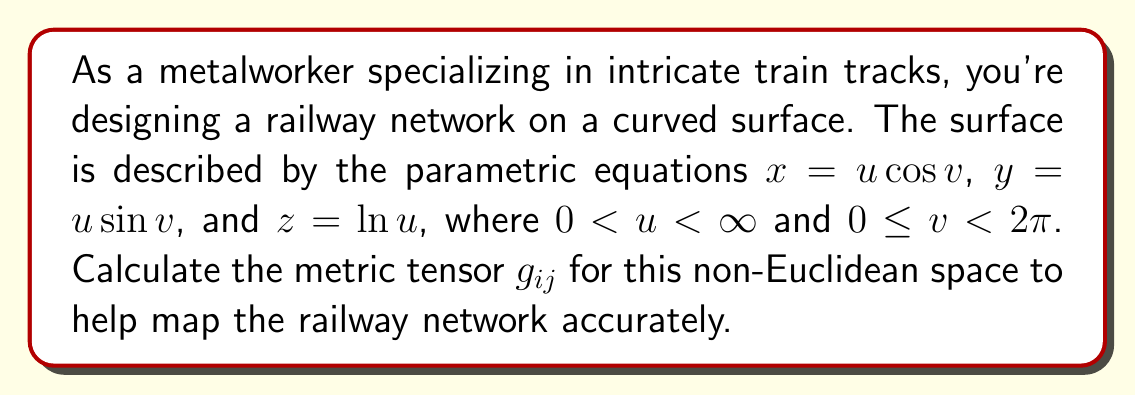Help me with this question. To calculate the metric tensor $g_{ij}$, we need to follow these steps:

1) First, we need to find the tangent vectors $\frac{\partial \vec{r}}{\partial u}$ and $\frac{\partial \vec{r}}{\partial v}$:

   $\frac{\partial \vec{r}}{\partial u} = (\cos v, \sin v, \frac{1}{u})$
   $\frac{\partial \vec{r}}{\partial v} = (-u \sin v, u \cos v, 0)$

2) The metric tensor $g_{ij}$ is defined as the dot product of these tangent vectors:

   $g_{11} = \frac{\partial \vec{r}}{\partial u} \cdot \frac{\partial \vec{r}}{\partial u}$
   $g_{12} = g_{21} = \frac{\partial \vec{r}}{\partial u} \cdot \frac{\partial \vec{r}}{\partial v}$
   $g_{22} = \frac{\partial \vec{r}}{\partial v} \cdot \frac{\partial \vec{r}}{\partial v}$

3) Let's calculate each component:

   $g_{11} = (\cos v)^2 + (\sin v)^2 + (\frac{1}{u})^2 = 1 + \frac{1}{u^2}$

   $g_{12} = g_{21} = \cos v (-u \sin v) + \sin v (u \cos v) + \frac{1}{u} \cdot 0 = 0$

   $g_{22} = (-u \sin v)^2 + (u \cos v)^2 + 0^2 = u^2 (\sin^2 v + \cos^2 v) = u^2$

4) Therefore, the metric tensor is:

   $$g_{ij} = \begin{pmatrix} 
   1 + \frac{1}{u^2} & 0 \\
   0 & u^2
   \end{pmatrix}$$

This metric tensor will allow accurate mapping of the railway network on this non-Euclidean surface.
Answer: $$g_{ij} = \begin{pmatrix} 
1 + \frac{1}{u^2} & 0 \\
0 & u^2
\end{pmatrix}$$ 